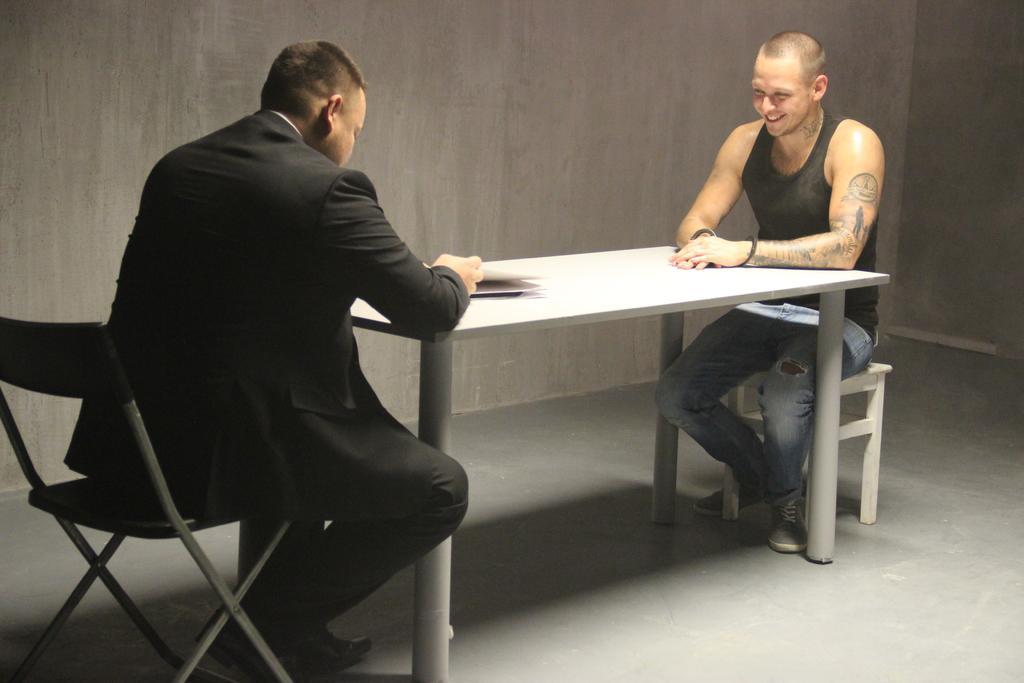In one or two sentences, can you explain what this image depicts? In this picture we can see two men sitting on chairs in front of a table opposite to each other. On the table we can see paper. This is a wall and floor. 